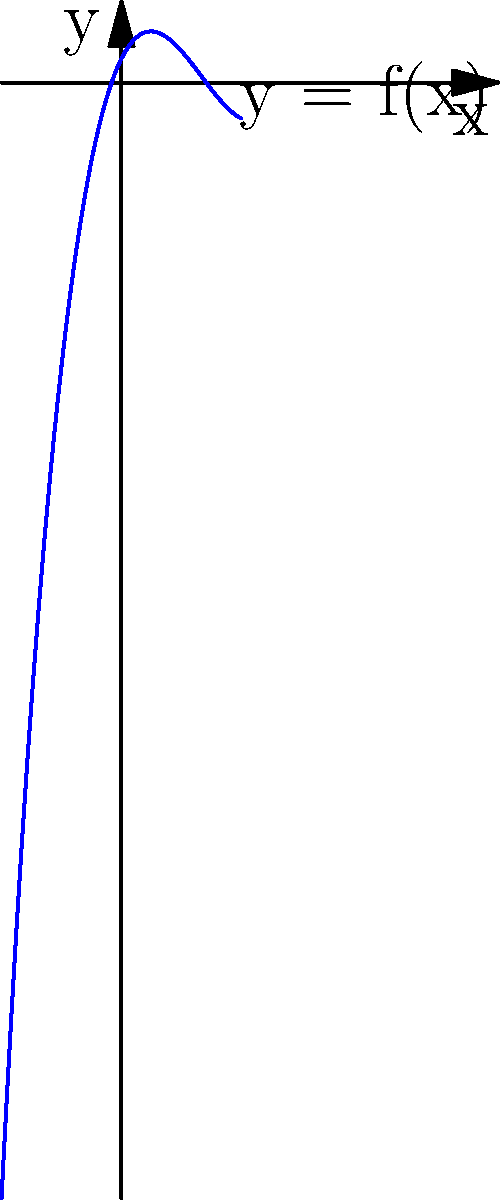In your journey of adapting to a new country, you've encountered various mathematical concepts. Let's consider a polynomial function represented by the graph above. Based on the end behavior of this function, determine its degree and the sign of its leading coefficient. To determine the degree and the sign of the leading coefficient of a polynomial based on its end behavior, we need to analyze how the function behaves as $x$ approaches positive and negative infinity.

Step 1: Observe the end behavior
- As $x$ approaches positive infinity, $y$ also approaches positive infinity.
- As $x$ approaches negative infinity, $y$ approaches negative infinity.

Step 2: Determine the degree
- The end behavior shows that the function grows without bound in both positive and negative directions.
- This behavior is characteristic of odd-degree polynomials.
- The simplest odd degree that could produce this behavior is 3.

Step 3: Determine the sign of the leading coefficient
- As $x$ approaches positive infinity, $y$ also approaches positive infinity.
- This indicates that the leading coefficient is positive.

Step 4: Confirm the results
- The observed behavior is consistent with a cubic function (degree 3) with a positive leading coefficient.
- An example of such a function would be $f(x) = ax^3 + bx^2 + cx + d$, where $a > 0$.
Answer: Degree: 3, Leading coefficient: Positive 